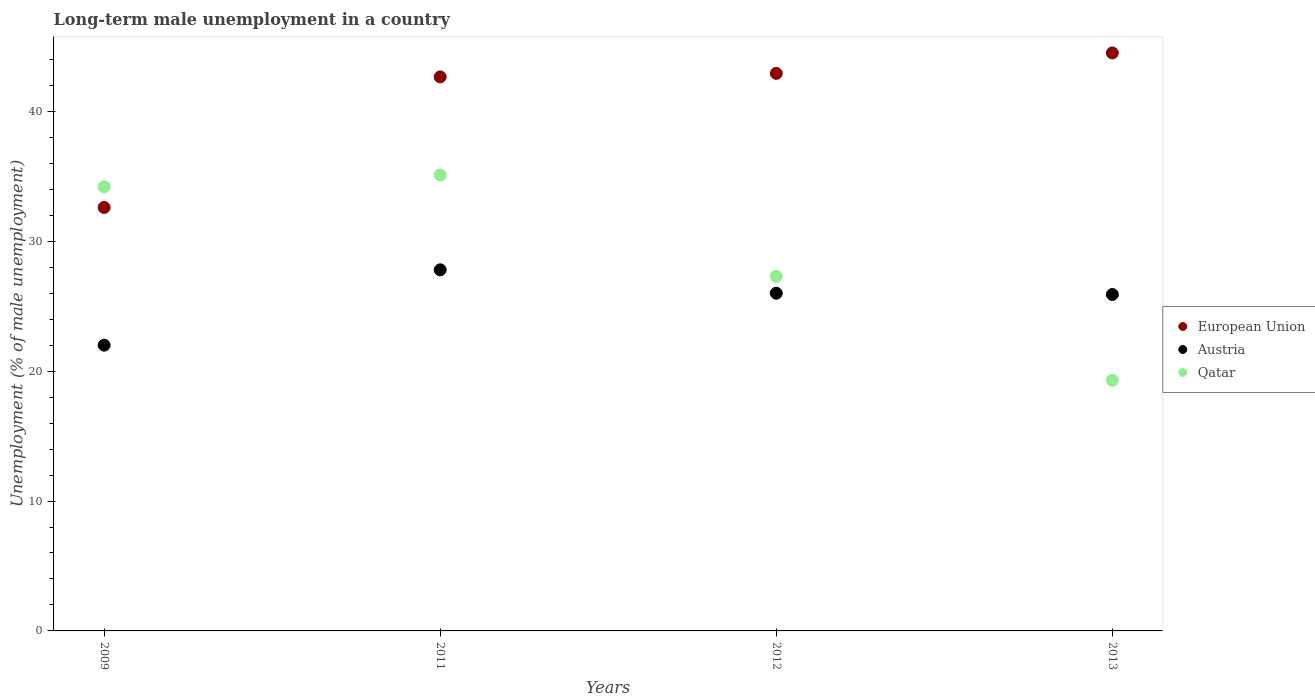Is the number of dotlines equal to the number of legend labels?
Keep it short and to the point. Yes. What is the percentage of long-term unemployed male population in Austria in 2011?
Make the answer very short. 27.8. Across all years, what is the maximum percentage of long-term unemployed male population in Qatar?
Offer a very short reply. 35.1. Across all years, what is the minimum percentage of long-term unemployed male population in Austria?
Your answer should be compact. 22. In which year was the percentage of long-term unemployed male population in European Union minimum?
Provide a short and direct response. 2009. What is the total percentage of long-term unemployed male population in Qatar in the graph?
Offer a terse response. 115.9. What is the difference between the percentage of long-term unemployed male population in Austria in 2009 and that in 2013?
Offer a very short reply. -3.9. What is the difference between the percentage of long-term unemployed male population in Austria in 2013 and the percentage of long-term unemployed male population in European Union in 2012?
Your response must be concise. -17.02. What is the average percentage of long-term unemployed male population in Austria per year?
Provide a succinct answer. 25.42. In the year 2011, what is the difference between the percentage of long-term unemployed male population in Qatar and percentage of long-term unemployed male population in Austria?
Offer a terse response. 7.3. What is the ratio of the percentage of long-term unemployed male population in Austria in 2009 to that in 2013?
Your answer should be compact. 0.85. Is the difference between the percentage of long-term unemployed male population in Qatar in 2009 and 2013 greater than the difference between the percentage of long-term unemployed male population in Austria in 2009 and 2013?
Your answer should be compact. Yes. What is the difference between the highest and the second highest percentage of long-term unemployed male population in Qatar?
Offer a very short reply. 0.9. What is the difference between the highest and the lowest percentage of long-term unemployed male population in Austria?
Give a very brief answer. 5.8. Is the sum of the percentage of long-term unemployed male population in Austria in 2009 and 2011 greater than the maximum percentage of long-term unemployed male population in Qatar across all years?
Give a very brief answer. Yes. How many dotlines are there?
Offer a terse response. 3. How many years are there in the graph?
Your answer should be compact. 4. What is the difference between two consecutive major ticks on the Y-axis?
Your answer should be compact. 10. Are the values on the major ticks of Y-axis written in scientific E-notation?
Keep it short and to the point. No. Does the graph contain grids?
Give a very brief answer. No. How many legend labels are there?
Provide a short and direct response. 3. How are the legend labels stacked?
Provide a short and direct response. Vertical. What is the title of the graph?
Your response must be concise. Long-term male unemployment in a country. Does "Antigua and Barbuda" appear as one of the legend labels in the graph?
Make the answer very short. No. What is the label or title of the X-axis?
Provide a succinct answer. Years. What is the label or title of the Y-axis?
Provide a short and direct response. Unemployment (% of male unemployment). What is the Unemployment (% of male unemployment) of European Union in 2009?
Give a very brief answer. 32.6. What is the Unemployment (% of male unemployment) in Austria in 2009?
Your response must be concise. 22. What is the Unemployment (% of male unemployment) of Qatar in 2009?
Ensure brevity in your answer.  34.2. What is the Unemployment (% of male unemployment) of European Union in 2011?
Make the answer very short. 42.65. What is the Unemployment (% of male unemployment) of Austria in 2011?
Provide a short and direct response. 27.8. What is the Unemployment (% of male unemployment) in Qatar in 2011?
Your response must be concise. 35.1. What is the Unemployment (% of male unemployment) of European Union in 2012?
Your response must be concise. 42.92. What is the Unemployment (% of male unemployment) in Austria in 2012?
Your response must be concise. 26. What is the Unemployment (% of male unemployment) in Qatar in 2012?
Your answer should be very brief. 27.3. What is the Unemployment (% of male unemployment) in European Union in 2013?
Provide a short and direct response. 44.5. What is the Unemployment (% of male unemployment) in Austria in 2013?
Your answer should be very brief. 25.9. What is the Unemployment (% of male unemployment) of Qatar in 2013?
Your answer should be compact. 19.3. Across all years, what is the maximum Unemployment (% of male unemployment) in European Union?
Provide a succinct answer. 44.5. Across all years, what is the maximum Unemployment (% of male unemployment) of Austria?
Offer a very short reply. 27.8. Across all years, what is the maximum Unemployment (% of male unemployment) in Qatar?
Offer a terse response. 35.1. Across all years, what is the minimum Unemployment (% of male unemployment) in European Union?
Offer a very short reply. 32.6. Across all years, what is the minimum Unemployment (% of male unemployment) in Qatar?
Provide a succinct answer. 19.3. What is the total Unemployment (% of male unemployment) of European Union in the graph?
Give a very brief answer. 162.68. What is the total Unemployment (% of male unemployment) of Austria in the graph?
Ensure brevity in your answer.  101.7. What is the total Unemployment (% of male unemployment) in Qatar in the graph?
Offer a terse response. 115.9. What is the difference between the Unemployment (% of male unemployment) of European Union in 2009 and that in 2011?
Give a very brief answer. -10.05. What is the difference between the Unemployment (% of male unemployment) in Austria in 2009 and that in 2011?
Your answer should be very brief. -5.8. What is the difference between the Unemployment (% of male unemployment) in Qatar in 2009 and that in 2011?
Ensure brevity in your answer.  -0.9. What is the difference between the Unemployment (% of male unemployment) of European Union in 2009 and that in 2012?
Offer a very short reply. -10.32. What is the difference between the Unemployment (% of male unemployment) of Austria in 2009 and that in 2012?
Keep it short and to the point. -4. What is the difference between the Unemployment (% of male unemployment) in Qatar in 2009 and that in 2012?
Ensure brevity in your answer.  6.9. What is the difference between the Unemployment (% of male unemployment) in European Union in 2009 and that in 2013?
Your answer should be compact. -11.89. What is the difference between the Unemployment (% of male unemployment) of European Union in 2011 and that in 2012?
Offer a terse response. -0.27. What is the difference between the Unemployment (% of male unemployment) in European Union in 2011 and that in 2013?
Offer a terse response. -1.84. What is the difference between the Unemployment (% of male unemployment) in Austria in 2011 and that in 2013?
Ensure brevity in your answer.  1.9. What is the difference between the Unemployment (% of male unemployment) of European Union in 2012 and that in 2013?
Your answer should be very brief. -1.57. What is the difference between the Unemployment (% of male unemployment) of Austria in 2012 and that in 2013?
Give a very brief answer. 0.1. What is the difference between the Unemployment (% of male unemployment) of Qatar in 2012 and that in 2013?
Give a very brief answer. 8. What is the difference between the Unemployment (% of male unemployment) of European Union in 2009 and the Unemployment (% of male unemployment) of Austria in 2011?
Offer a very short reply. 4.8. What is the difference between the Unemployment (% of male unemployment) of European Union in 2009 and the Unemployment (% of male unemployment) of Qatar in 2011?
Offer a very short reply. -2.5. What is the difference between the Unemployment (% of male unemployment) in Austria in 2009 and the Unemployment (% of male unemployment) in Qatar in 2011?
Your answer should be very brief. -13.1. What is the difference between the Unemployment (% of male unemployment) in European Union in 2009 and the Unemployment (% of male unemployment) in Austria in 2012?
Make the answer very short. 6.6. What is the difference between the Unemployment (% of male unemployment) in European Union in 2009 and the Unemployment (% of male unemployment) in Qatar in 2012?
Offer a terse response. 5.3. What is the difference between the Unemployment (% of male unemployment) in Austria in 2009 and the Unemployment (% of male unemployment) in Qatar in 2012?
Provide a succinct answer. -5.3. What is the difference between the Unemployment (% of male unemployment) of European Union in 2009 and the Unemployment (% of male unemployment) of Austria in 2013?
Ensure brevity in your answer.  6.7. What is the difference between the Unemployment (% of male unemployment) in European Union in 2009 and the Unemployment (% of male unemployment) in Qatar in 2013?
Ensure brevity in your answer.  13.3. What is the difference between the Unemployment (% of male unemployment) in Austria in 2009 and the Unemployment (% of male unemployment) in Qatar in 2013?
Offer a very short reply. 2.7. What is the difference between the Unemployment (% of male unemployment) of European Union in 2011 and the Unemployment (% of male unemployment) of Austria in 2012?
Keep it short and to the point. 16.65. What is the difference between the Unemployment (% of male unemployment) in European Union in 2011 and the Unemployment (% of male unemployment) in Qatar in 2012?
Ensure brevity in your answer.  15.35. What is the difference between the Unemployment (% of male unemployment) of Austria in 2011 and the Unemployment (% of male unemployment) of Qatar in 2012?
Give a very brief answer. 0.5. What is the difference between the Unemployment (% of male unemployment) in European Union in 2011 and the Unemployment (% of male unemployment) in Austria in 2013?
Your answer should be compact. 16.75. What is the difference between the Unemployment (% of male unemployment) in European Union in 2011 and the Unemployment (% of male unemployment) in Qatar in 2013?
Provide a short and direct response. 23.35. What is the difference between the Unemployment (% of male unemployment) of Austria in 2011 and the Unemployment (% of male unemployment) of Qatar in 2013?
Provide a succinct answer. 8.5. What is the difference between the Unemployment (% of male unemployment) in European Union in 2012 and the Unemployment (% of male unemployment) in Austria in 2013?
Give a very brief answer. 17.02. What is the difference between the Unemployment (% of male unemployment) of European Union in 2012 and the Unemployment (% of male unemployment) of Qatar in 2013?
Give a very brief answer. 23.62. What is the difference between the Unemployment (% of male unemployment) in Austria in 2012 and the Unemployment (% of male unemployment) in Qatar in 2013?
Ensure brevity in your answer.  6.7. What is the average Unemployment (% of male unemployment) of European Union per year?
Your response must be concise. 40.67. What is the average Unemployment (% of male unemployment) in Austria per year?
Offer a terse response. 25.43. What is the average Unemployment (% of male unemployment) in Qatar per year?
Give a very brief answer. 28.98. In the year 2009, what is the difference between the Unemployment (% of male unemployment) in European Union and Unemployment (% of male unemployment) in Austria?
Your answer should be compact. 10.6. In the year 2009, what is the difference between the Unemployment (% of male unemployment) in European Union and Unemployment (% of male unemployment) in Qatar?
Make the answer very short. -1.6. In the year 2011, what is the difference between the Unemployment (% of male unemployment) in European Union and Unemployment (% of male unemployment) in Austria?
Make the answer very short. 14.85. In the year 2011, what is the difference between the Unemployment (% of male unemployment) in European Union and Unemployment (% of male unemployment) in Qatar?
Ensure brevity in your answer.  7.55. In the year 2012, what is the difference between the Unemployment (% of male unemployment) of European Union and Unemployment (% of male unemployment) of Austria?
Ensure brevity in your answer.  16.92. In the year 2012, what is the difference between the Unemployment (% of male unemployment) in European Union and Unemployment (% of male unemployment) in Qatar?
Offer a terse response. 15.62. In the year 2013, what is the difference between the Unemployment (% of male unemployment) of European Union and Unemployment (% of male unemployment) of Austria?
Provide a short and direct response. 18.6. In the year 2013, what is the difference between the Unemployment (% of male unemployment) of European Union and Unemployment (% of male unemployment) of Qatar?
Provide a succinct answer. 25.2. What is the ratio of the Unemployment (% of male unemployment) of European Union in 2009 to that in 2011?
Offer a very short reply. 0.76. What is the ratio of the Unemployment (% of male unemployment) of Austria in 2009 to that in 2011?
Your response must be concise. 0.79. What is the ratio of the Unemployment (% of male unemployment) of Qatar in 2009 to that in 2011?
Offer a terse response. 0.97. What is the ratio of the Unemployment (% of male unemployment) in European Union in 2009 to that in 2012?
Provide a short and direct response. 0.76. What is the ratio of the Unemployment (% of male unemployment) of Austria in 2009 to that in 2012?
Offer a very short reply. 0.85. What is the ratio of the Unemployment (% of male unemployment) of Qatar in 2009 to that in 2012?
Ensure brevity in your answer.  1.25. What is the ratio of the Unemployment (% of male unemployment) in European Union in 2009 to that in 2013?
Your answer should be compact. 0.73. What is the ratio of the Unemployment (% of male unemployment) of Austria in 2009 to that in 2013?
Keep it short and to the point. 0.85. What is the ratio of the Unemployment (% of male unemployment) in Qatar in 2009 to that in 2013?
Make the answer very short. 1.77. What is the ratio of the Unemployment (% of male unemployment) of European Union in 2011 to that in 2012?
Make the answer very short. 0.99. What is the ratio of the Unemployment (% of male unemployment) in Austria in 2011 to that in 2012?
Provide a short and direct response. 1.07. What is the ratio of the Unemployment (% of male unemployment) in Qatar in 2011 to that in 2012?
Your answer should be very brief. 1.29. What is the ratio of the Unemployment (% of male unemployment) in European Union in 2011 to that in 2013?
Ensure brevity in your answer.  0.96. What is the ratio of the Unemployment (% of male unemployment) of Austria in 2011 to that in 2013?
Offer a terse response. 1.07. What is the ratio of the Unemployment (% of male unemployment) of Qatar in 2011 to that in 2013?
Provide a short and direct response. 1.82. What is the ratio of the Unemployment (% of male unemployment) in European Union in 2012 to that in 2013?
Keep it short and to the point. 0.96. What is the ratio of the Unemployment (% of male unemployment) of Austria in 2012 to that in 2013?
Offer a very short reply. 1. What is the ratio of the Unemployment (% of male unemployment) in Qatar in 2012 to that in 2013?
Provide a short and direct response. 1.41. What is the difference between the highest and the second highest Unemployment (% of male unemployment) of European Union?
Provide a short and direct response. 1.57. What is the difference between the highest and the second highest Unemployment (% of male unemployment) in Austria?
Give a very brief answer. 1.8. What is the difference between the highest and the lowest Unemployment (% of male unemployment) of European Union?
Give a very brief answer. 11.89. What is the difference between the highest and the lowest Unemployment (% of male unemployment) of Austria?
Make the answer very short. 5.8. What is the difference between the highest and the lowest Unemployment (% of male unemployment) in Qatar?
Your answer should be very brief. 15.8. 